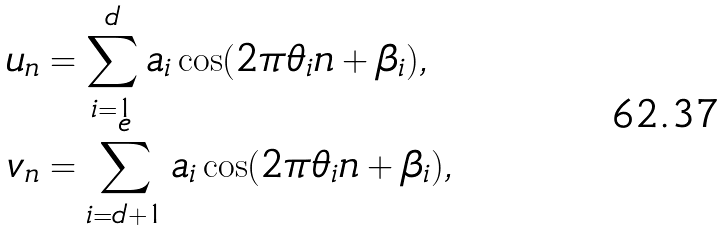<formula> <loc_0><loc_0><loc_500><loc_500>u _ { n } & = \sum _ { i = 1 } ^ { d } a _ { i } \cos ( 2 \pi \theta _ { i } n + \beta _ { i } ) , \\ v _ { n } & = \sum _ { i = d + 1 } ^ { e } a _ { i } \cos ( 2 \pi \theta _ { i } n + \beta _ { i } ) ,</formula> 